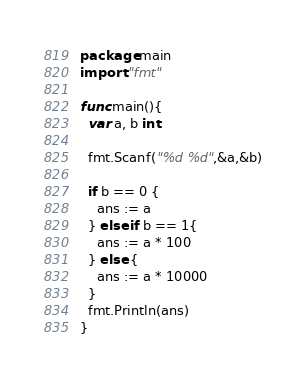Convert code to text. <code><loc_0><loc_0><loc_500><loc_500><_Go_>package main
import "fmt"

func main(){
  var a, b int
  
  fmt.Scanf("%d %d",&a,&b)
  
  if b == 0 {
    ans := a
  } else if b == 1{
    ans := a * 100
  } else {
    ans := a * 10000
  }
  fmt.Println(ans)
}
</code> 